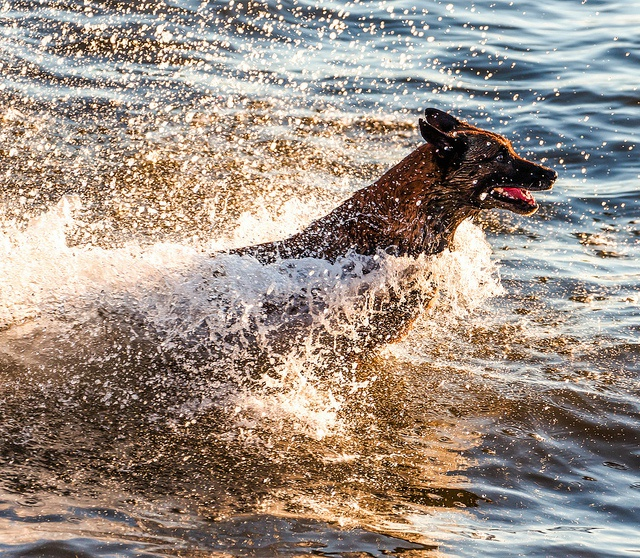Describe the objects in this image and their specific colors. I can see a dog in darkgray, black, maroon, and lightgray tones in this image. 